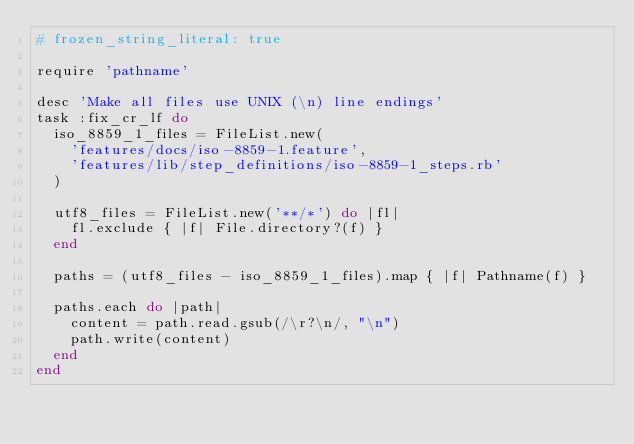<code> <loc_0><loc_0><loc_500><loc_500><_Ruby_># frozen_string_literal: true

require 'pathname'

desc 'Make all files use UNIX (\n) line endings'
task :fix_cr_lf do
  iso_8859_1_files = FileList.new(
    'features/docs/iso-8859-1.feature',
    'features/lib/step_definitions/iso-8859-1_steps.rb'
  )

  utf8_files = FileList.new('**/*') do |fl|
    fl.exclude { |f| File.directory?(f) }
  end

  paths = (utf8_files - iso_8859_1_files).map { |f| Pathname(f) }

  paths.each do |path|
    content = path.read.gsub(/\r?\n/, "\n")
    path.write(content)
  end
end
</code> 